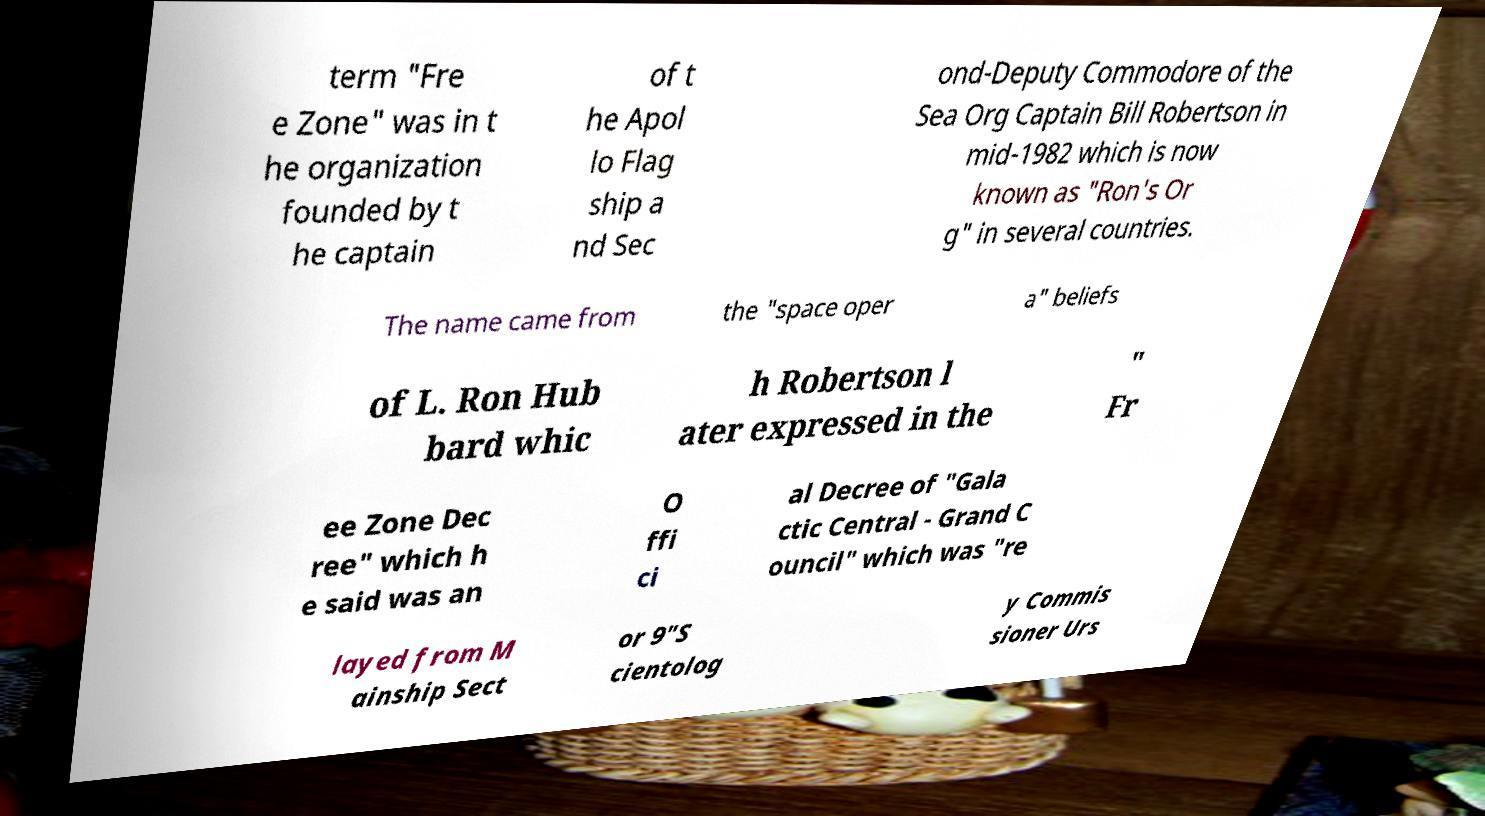Can you accurately transcribe the text from the provided image for me? term "Fre e Zone" was in t he organization founded by t he captain of t he Apol lo Flag ship a nd Sec ond-Deputy Commodore of the Sea Org Captain Bill Robertson in mid-1982 which is now known as "Ron's Or g" in several countries. The name came from the "space oper a" beliefs of L. Ron Hub bard whic h Robertson l ater expressed in the " Fr ee Zone Dec ree" which h e said was an O ffi ci al Decree of "Gala ctic Central - Grand C ouncil" which was "re layed from M ainship Sect or 9"S cientolog y Commis sioner Urs 